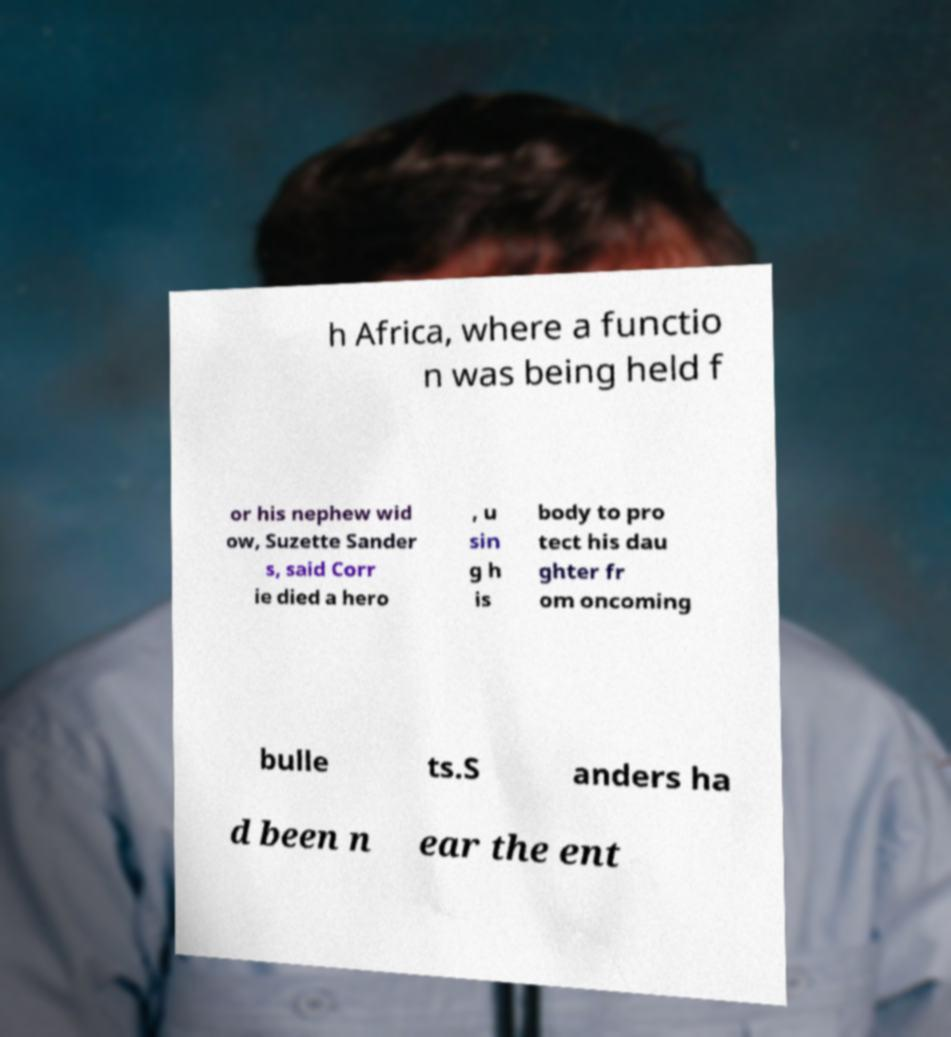Can you read and provide the text displayed in the image?This photo seems to have some interesting text. Can you extract and type it out for me? h Africa, where a functio n was being held f or his nephew wid ow, Suzette Sander s, said Corr ie died a hero , u sin g h is body to pro tect his dau ghter fr om oncoming bulle ts.S anders ha d been n ear the ent 